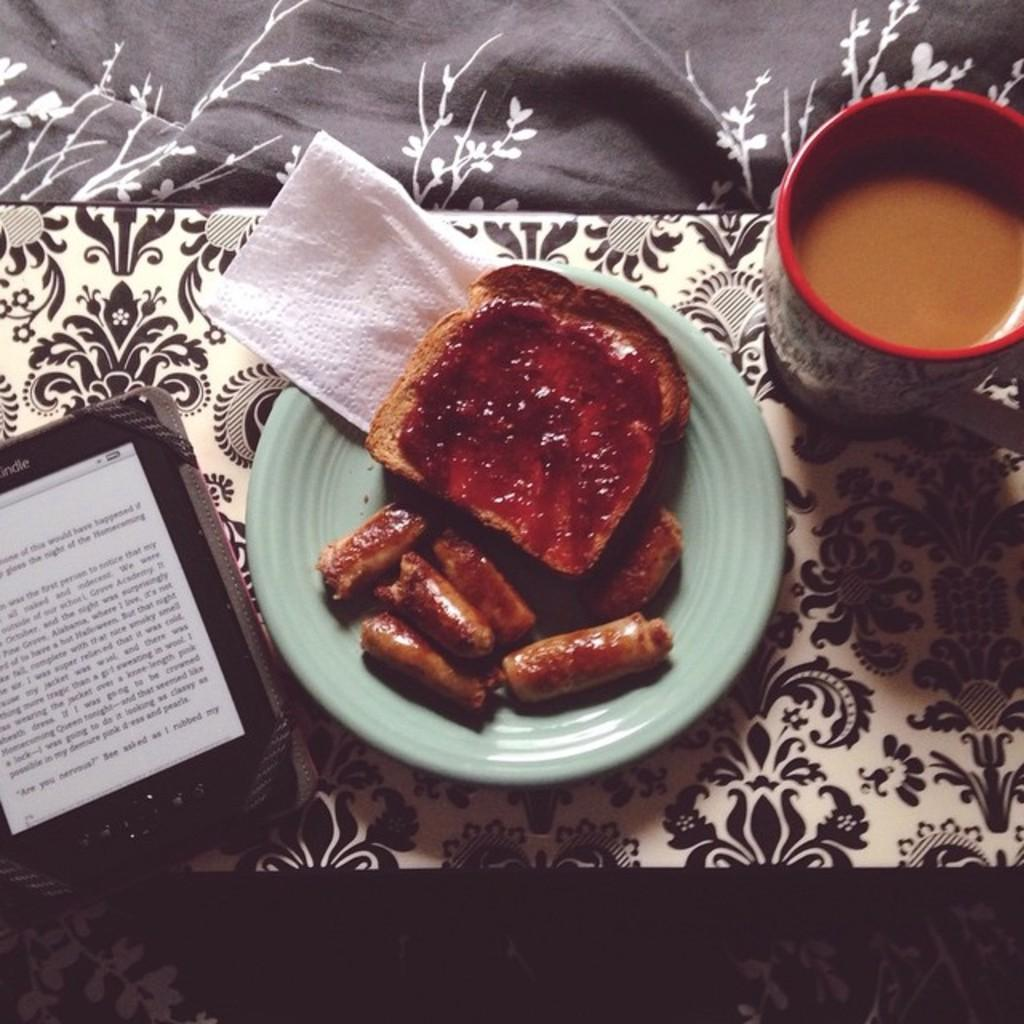<image>
Present a compact description of the photo's key features. Plate of breakfast next to an ereader which ends the page saying "Rubbed my". 